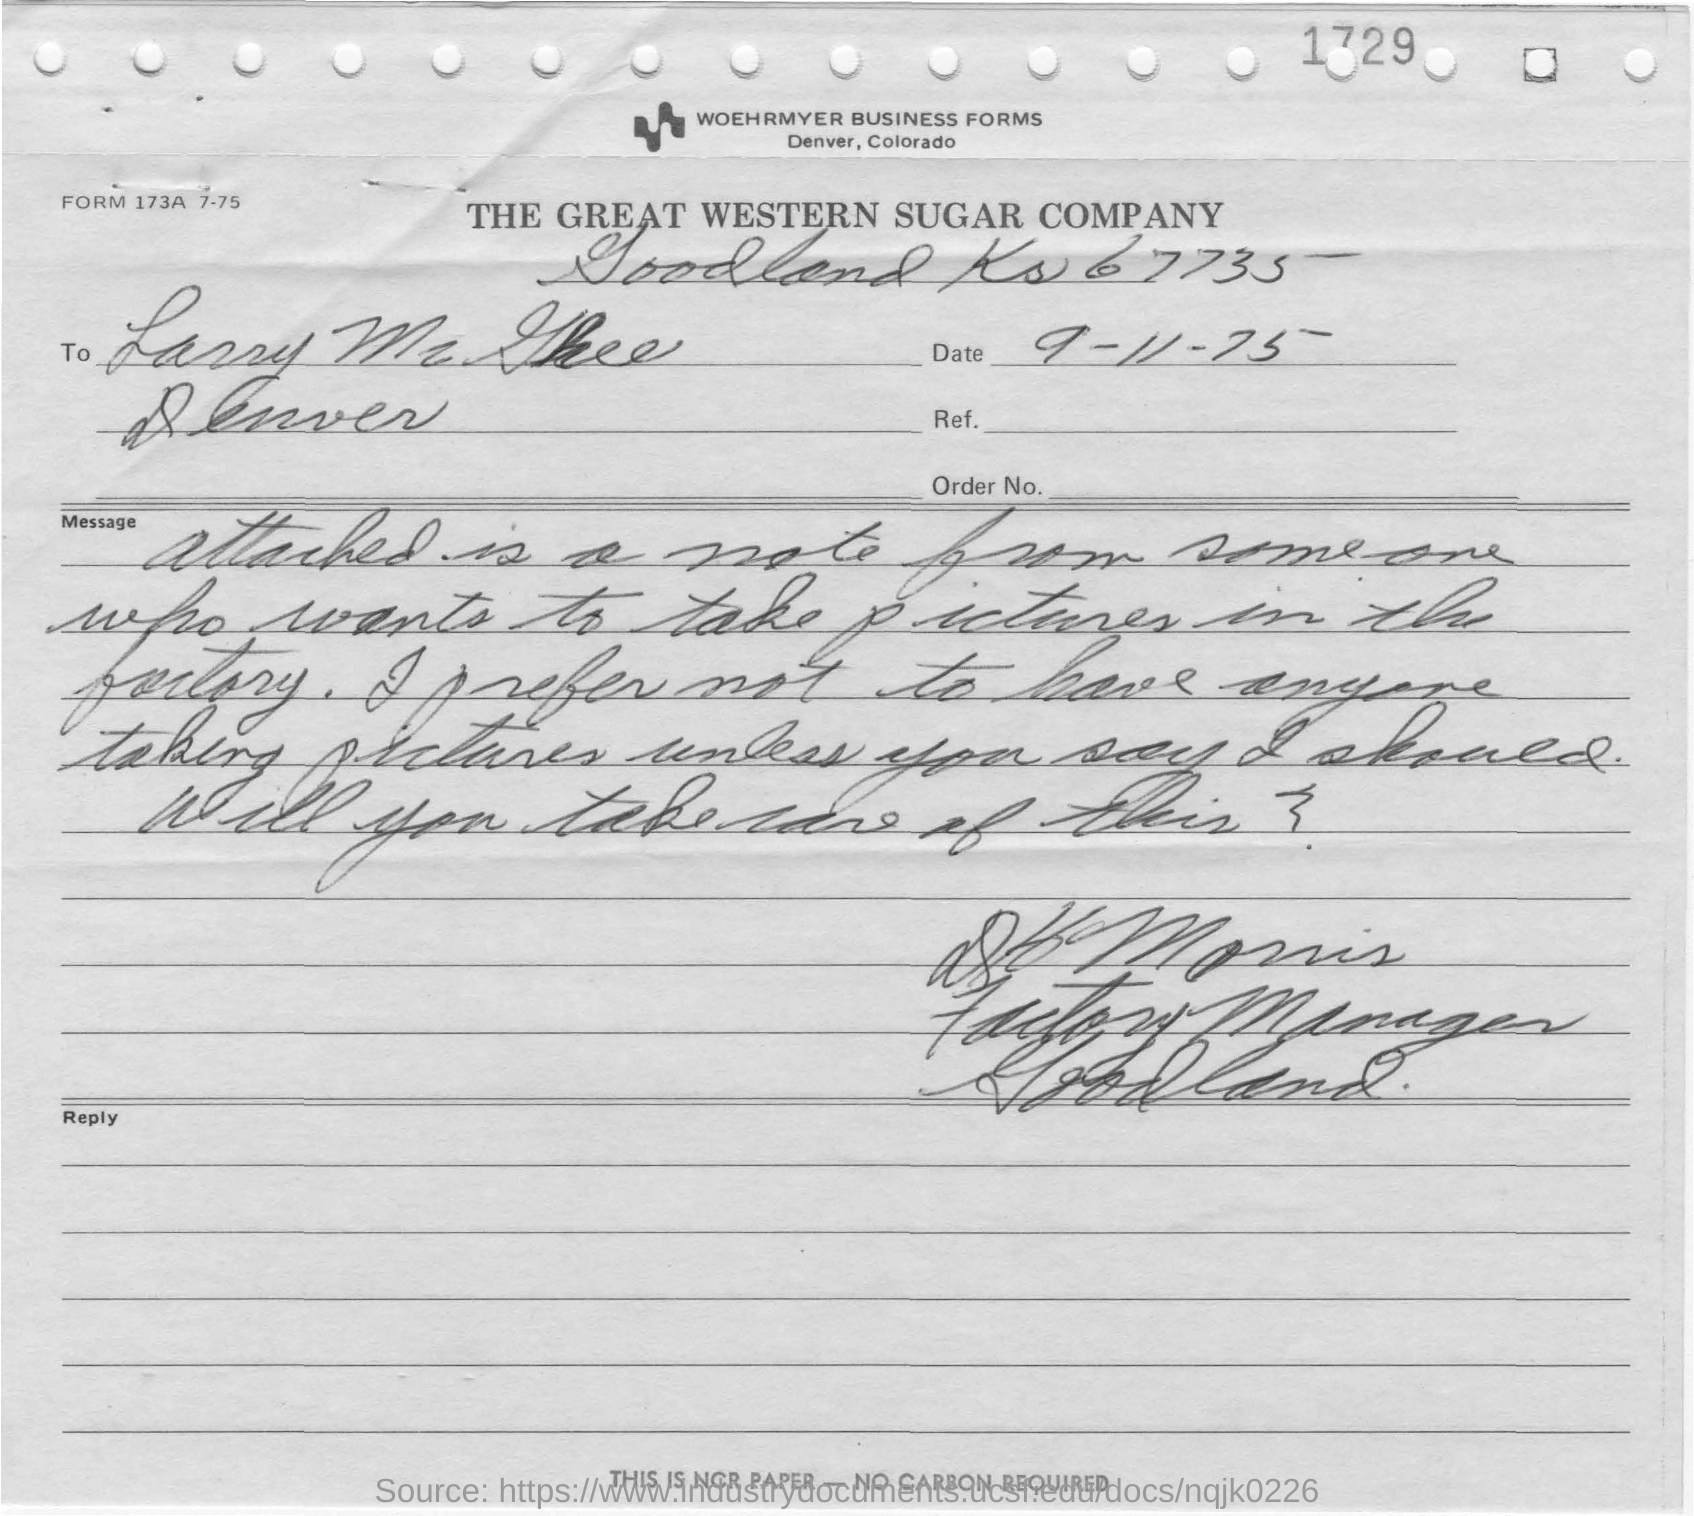What is the date mentioned in the form?
Provide a short and direct response. 9-11-75. 